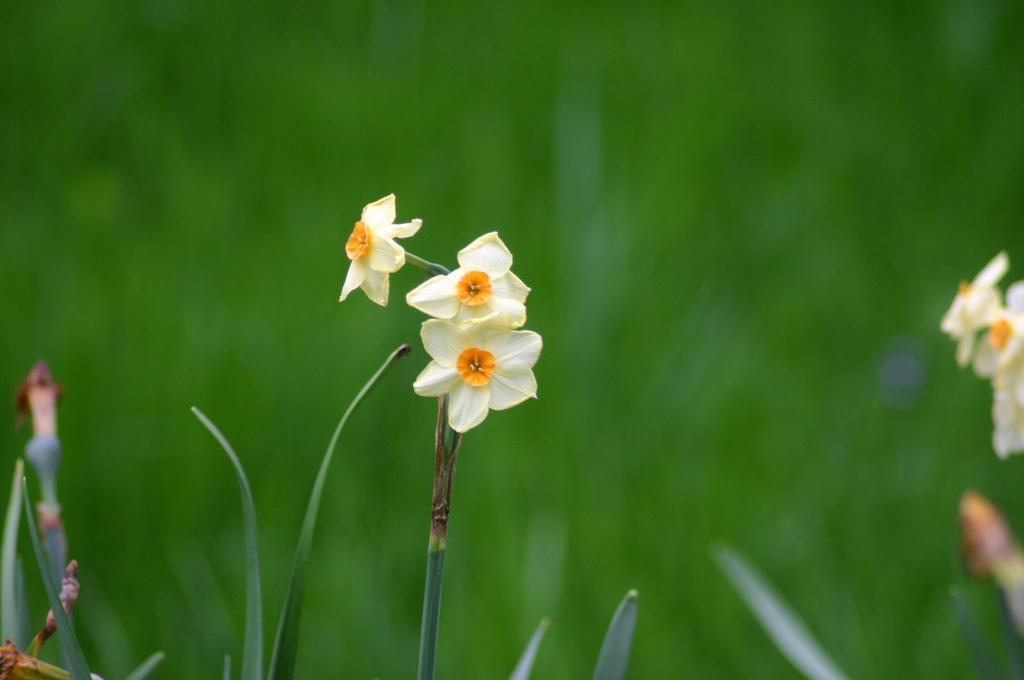Could you give a brief overview of what you see in this image? In the middle of the image we can see some flowers. Background of the image is blur. 